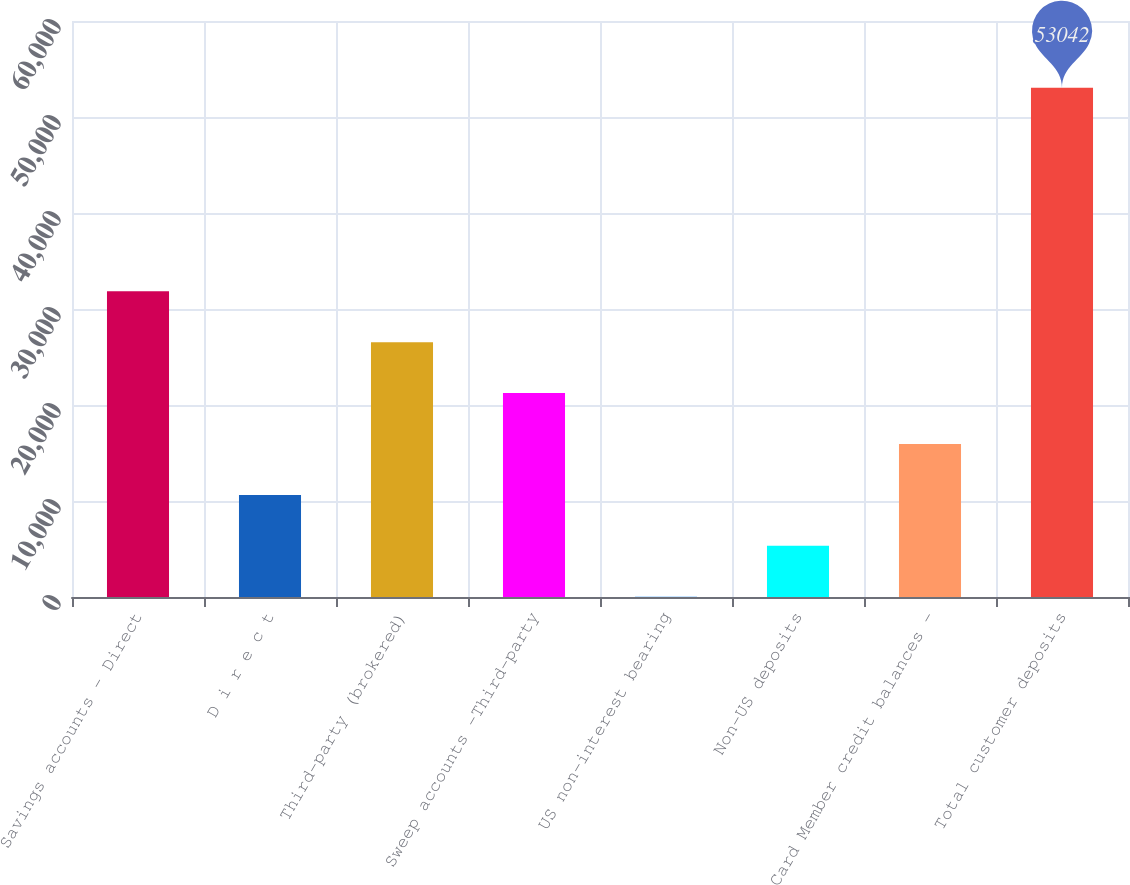Convert chart. <chart><loc_0><loc_0><loc_500><loc_500><bar_chart><fcel>Savings accounts - Direct<fcel>D i r e c t<fcel>Third-party (brokered)<fcel>Sweep accounts -Third-party<fcel>US non-interest bearing<fcel>Non-US deposits<fcel>Card Member credit balances -<fcel>Total customer deposits<nl><fcel>31839.6<fcel>10637.2<fcel>26539<fcel>21238.4<fcel>36<fcel>5336.6<fcel>15937.8<fcel>53042<nl></chart> 